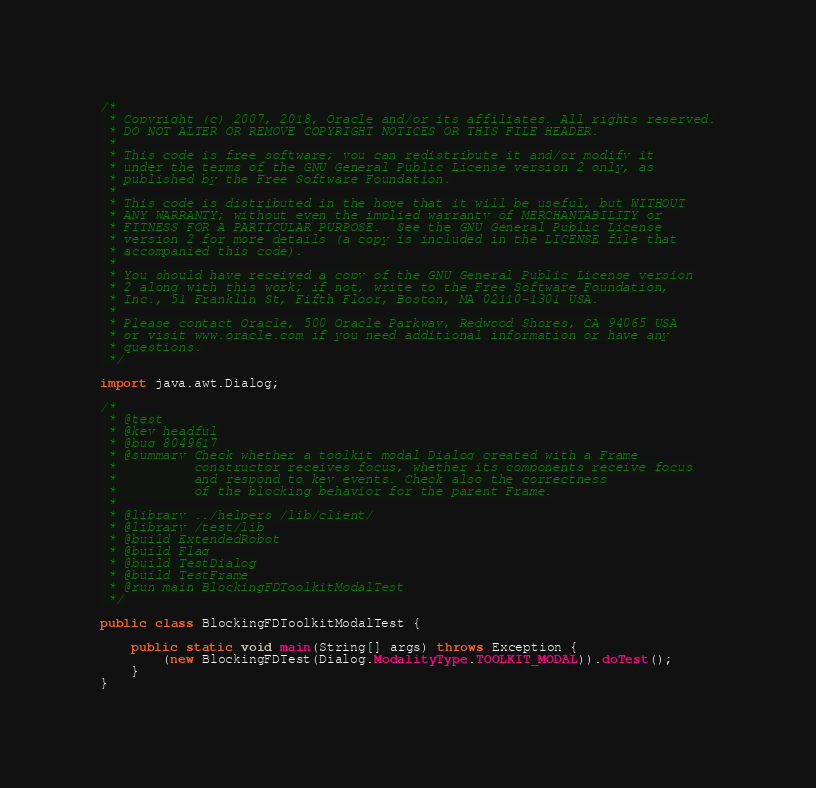Convert code to text. <code><loc_0><loc_0><loc_500><loc_500><_Java_>/*
 * Copyright (c) 2007, 2018, Oracle and/or its affiliates. All rights reserved.
 * DO NOT ALTER OR REMOVE COPYRIGHT NOTICES OR THIS FILE HEADER.
 *
 * This code is free software; you can redistribute it and/or modify it
 * under the terms of the GNU General Public License version 2 only, as
 * published by the Free Software Foundation.
 *
 * This code is distributed in the hope that it will be useful, but WITHOUT
 * ANY WARRANTY; without even the implied warranty of MERCHANTABILITY or
 * FITNESS FOR A PARTICULAR PURPOSE.  See the GNU General Public License
 * version 2 for more details (a copy is included in the LICENSE file that
 * accompanied this code).
 *
 * You should have received a copy of the GNU General Public License version
 * 2 along with this work; if not, write to the Free Software Foundation,
 * Inc., 51 Franklin St, Fifth Floor, Boston, MA 02110-1301 USA.
 *
 * Please contact Oracle, 500 Oracle Parkway, Redwood Shores, CA 94065 USA
 * or visit www.oracle.com if you need additional information or have any
 * questions.
 */

import java.awt.Dialog;

/*
 * @test
 * @key headful
 * @bug 8049617
 * @summary Check whether a toolkit modal Dialog created with a Frame
 *          constructor receives focus, whether its components receive focus
 *          and respond to key events. Check also the correctness
 *          of the blocking behavior for the parent Frame.
 *
 * @library ../helpers /lib/client/
 * @library /test/lib
 * @build ExtendedRobot
 * @build Flag
 * @build TestDialog
 * @build TestFrame
 * @run main BlockingFDToolkitModalTest
 */

public class BlockingFDToolkitModalTest {

    public static void main(String[] args) throws Exception {
        (new BlockingFDTest(Dialog.ModalityType.TOOLKIT_MODAL)).doTest();
    }
}
</code> 